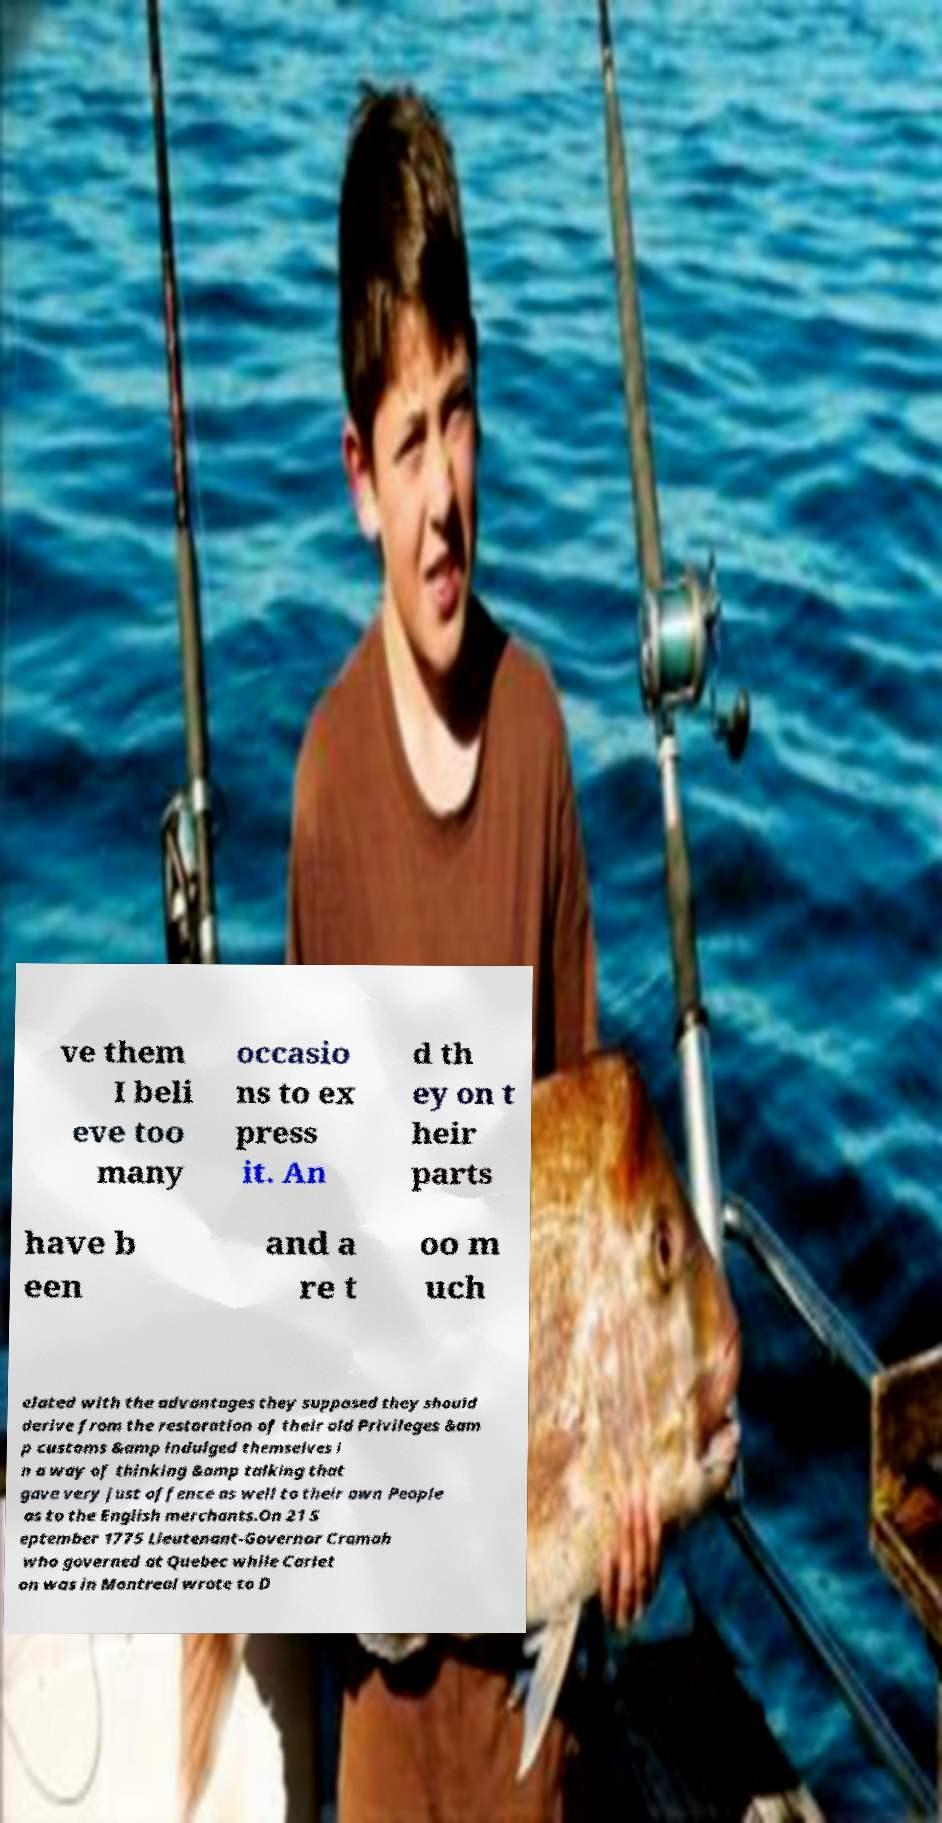Could you assist in decoding the text presented in this image and type it out clearly? ve them I beli eve too many occasio ns to ex press it. An d th ey on t heir parts have b een and a re t oo m uch elated with the advantages they supposed they should derive from the restoration of their old Privileges &am p customs &amp indulged themselves i n a way of thinking &amp talking that gave very just offence as well to their own People as to the English merchants.On 21 S eptember 1775 Lieutenant-Governor Cramah who governed at Quebec while Carlet on was in Montreal wrote to D 